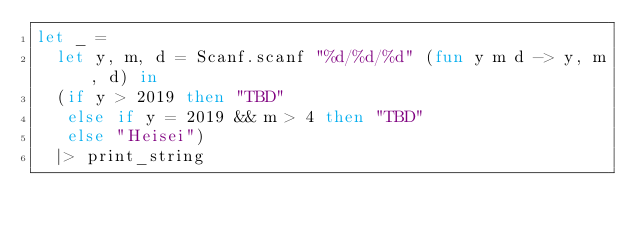<code> <loc_0><loc_0><loc_500><loc_500><_OCaml_>let _ =
  let y, m, d = Scanf.scanf "%d/%d/%d" (fun y m d -> y, m, d) in
  (if y > 2019 then "TBD"
   else if y = 2019 && m > 4 then "TBD"
   else "Heisei")
  |> print_string</code> 